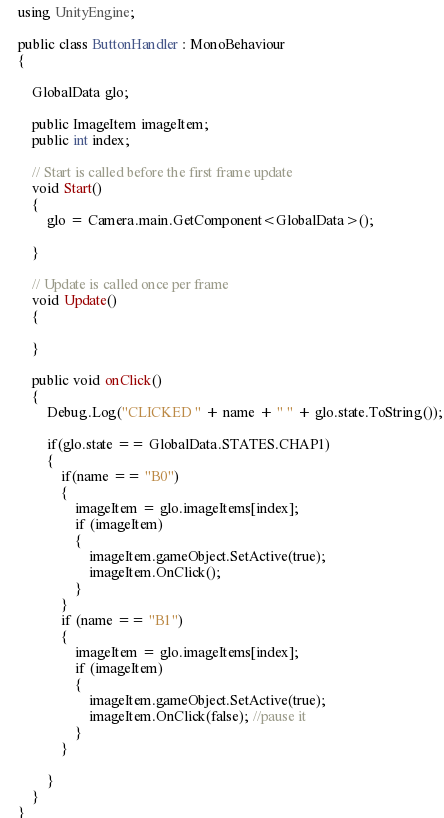<code> <loc_0><loc_0><loc_500><loc_500><_C#_>using UnityEngine;

public class ButtonHandler : MonoBehaviour
{

    GlobalData glo;

    public ImageItem imageItem;
    public int index;
    
    // Start is called before the first frame update
    void Start()
    {
        glo = Camera.main.GetComponent<GlobalData>();
        
    }

    // Update is called once per frame
    void Update()
    {
        
    }

    public void onClick()
    {
        Debug.Log("CLICKED " + name + " " + glo.state.ToString());

        if(glo.state == GlobalData.STATES.CHAP1)
        {
            if(name == "B0")
            {
                imageItem = glo.imageItems[index];
                if (imageItem)
                {
                    imageItem.gameObject.SetActive(true);
                    imageItem.OnClick();
                }
            }
            if (name == "B1")
            {
                imageItem = glo.imageItems[index];
                if (imageItem)
                {
                    imageItem.gameObject.SetActive(true);
                    imageItem.OnClick(false); //pause it
                }
            }

        }
    }
}
</code> 